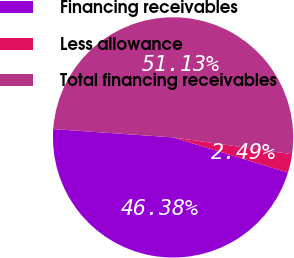<chart> <loc_0><loc_0><loc_500><loc_500><pie_chart><fcel>Financing receivables<fcel>Less allowance<fcel>Total financing receivables<nl><fcel>46.38%<fcel>2.49%<fcel>51.13%<nl></chart> 